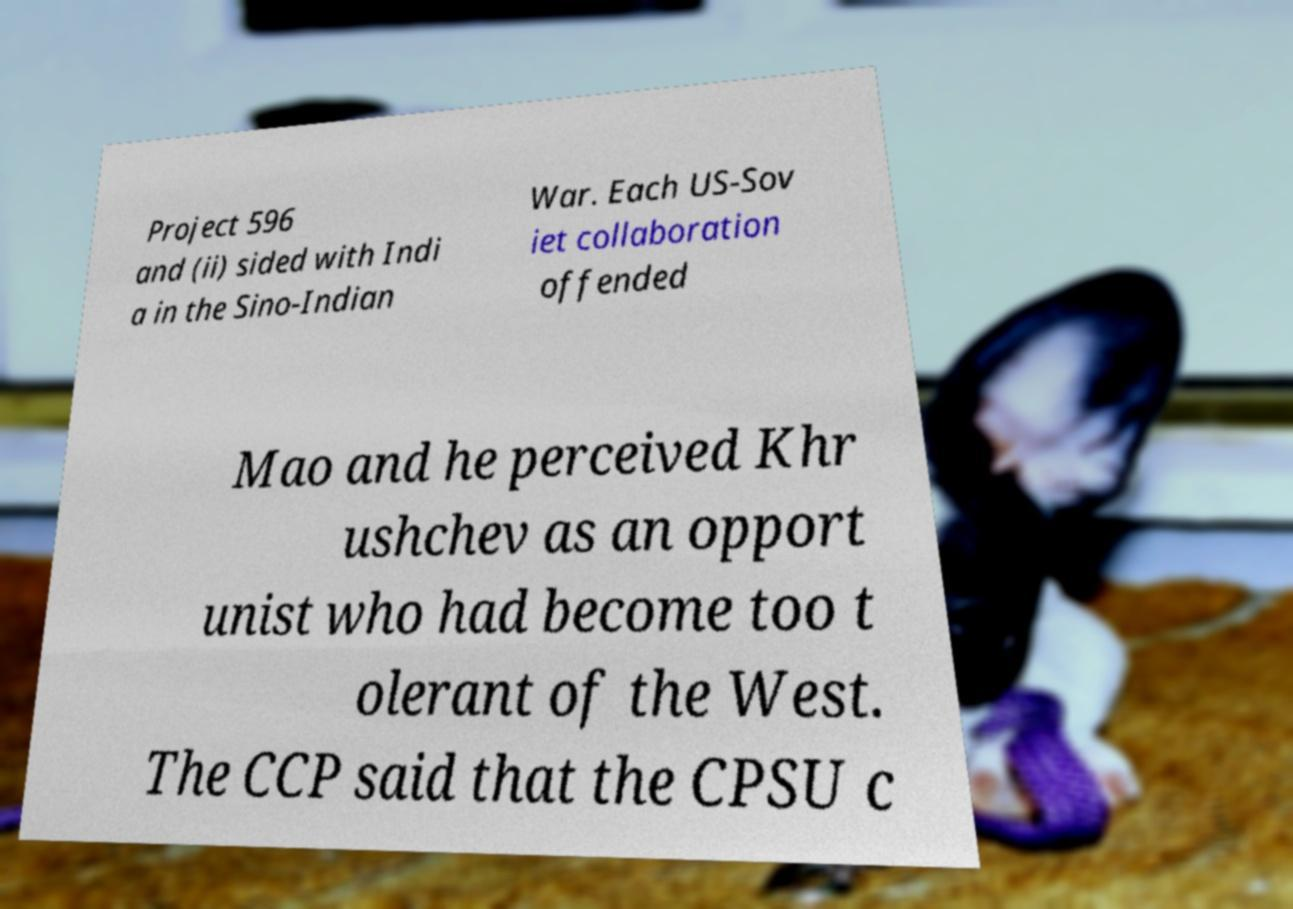What messages or text are displayed in this image? I need them in a readable, typed format. Project 596 and (ii) sided with Indi a in the Sino-Indian War. Each US-Sov iet collaboration offended Mao and he perceived Khr ushchev as an opport unist who had become too t olerant of the West. The CCP said that the CPSU c 